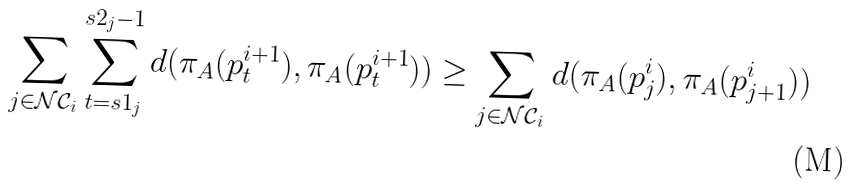Convert formula to latex. <formula><loc_0><loc_0><loc_500><loc_500>\sum _ { j \in \mathcal { N C } _ { i } } \sum _ { t = s 1 _ { j } } ^ { s 2 _ { j } - 1 } d ( \pi _ { A } ( p _ { t } ^ { i + 1 } ) , \pi _ { A } ( p _ { t } ^ { i + 1 } ) ) \geq \sum _ { j \in \mathcal { N C } _ { i } } d ( \pi _ { A } ( p _ { j } ^ { i } ) , \pi _ { A } ( p _ { j + 1 } ^ { i } ) )</formula> 